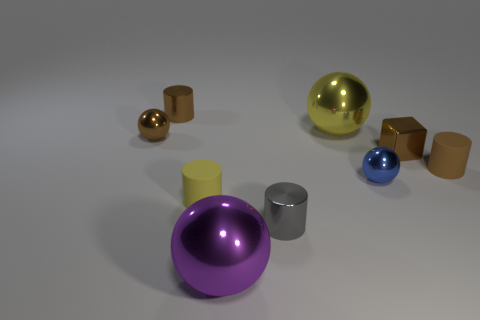Do the yellow thing in front of the tiny brown rubber object and the rubber cylinder on the right side of the yellow sphere have the same size?
Ensure brevity in your answer.  Yes. Is there a small brown cube made of the same material as the yellow cylinder?
Offer a terse response. No. How many things are tiny objects that are behind the tiny blue metal thing or big spheres?
Offer a terse response. 6. Does the tiny brown cylinder in front of the tiny brown metal block have the same material as the yellow cylinder?
Your response must be concise. Yes. Is the shape of the blue metal object the same as the small gray thing?
Ensure brevity in your answer.  No. How many cubes are behind the rubber thing that is right of the big yellow ball?
Your answer should be compact. 1. What material is the brown object that is the same shape as the purple shiny thing?
Your answer should be very brief. Metal. There is a large sphere that is in front of the gray metal thing; does it have the same color as the tiny block?
Make the answer very short. No. Is the material of the large yellow object the same as the large object in front of the tiny brown matte cylinder?
Ensure brevity in your answer.  Yes. The tiny brown rubber thing to the right of the tiny blue object has what shape?
Provide a short and direct response. Cylinder. 